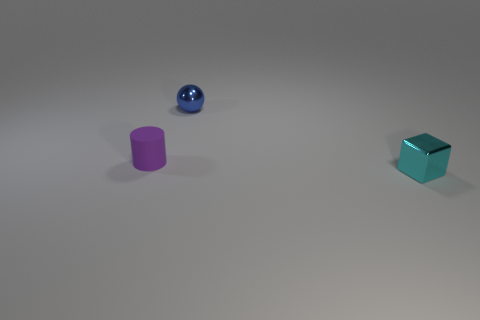Can you imagine a story or a setting where these three distinct objects might naturally occur together? Certainly! Imagine a futuristic setting in a child's playroom, where toys are crafted from various materials to teach about shapes and substances. The metallic cube could be a puzzle box that sharpens logical thinking; the blue sphere might be a buoyant ball for physics experiments; and the purple cylinder could double as a rolling pin for creative clay modeling. Together they form a triad of interactive learning tools, each engaging the child in different aspects of exploratory play. 